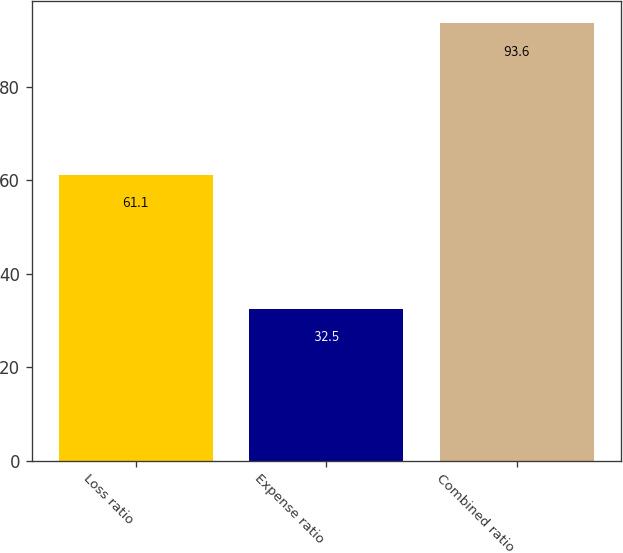Convert chart to OTSL. <chart><loc_0><loc_0><loc_500><loc_500><bar_chart><fcel>Loss ratio<fcel>Expense ratio<fcel>Combined ratio<nl><fcel>61.1<fcel>32.5<fcel>93.6<nl></chart> 